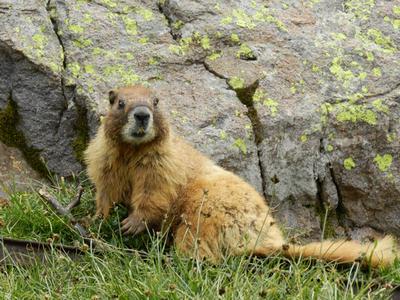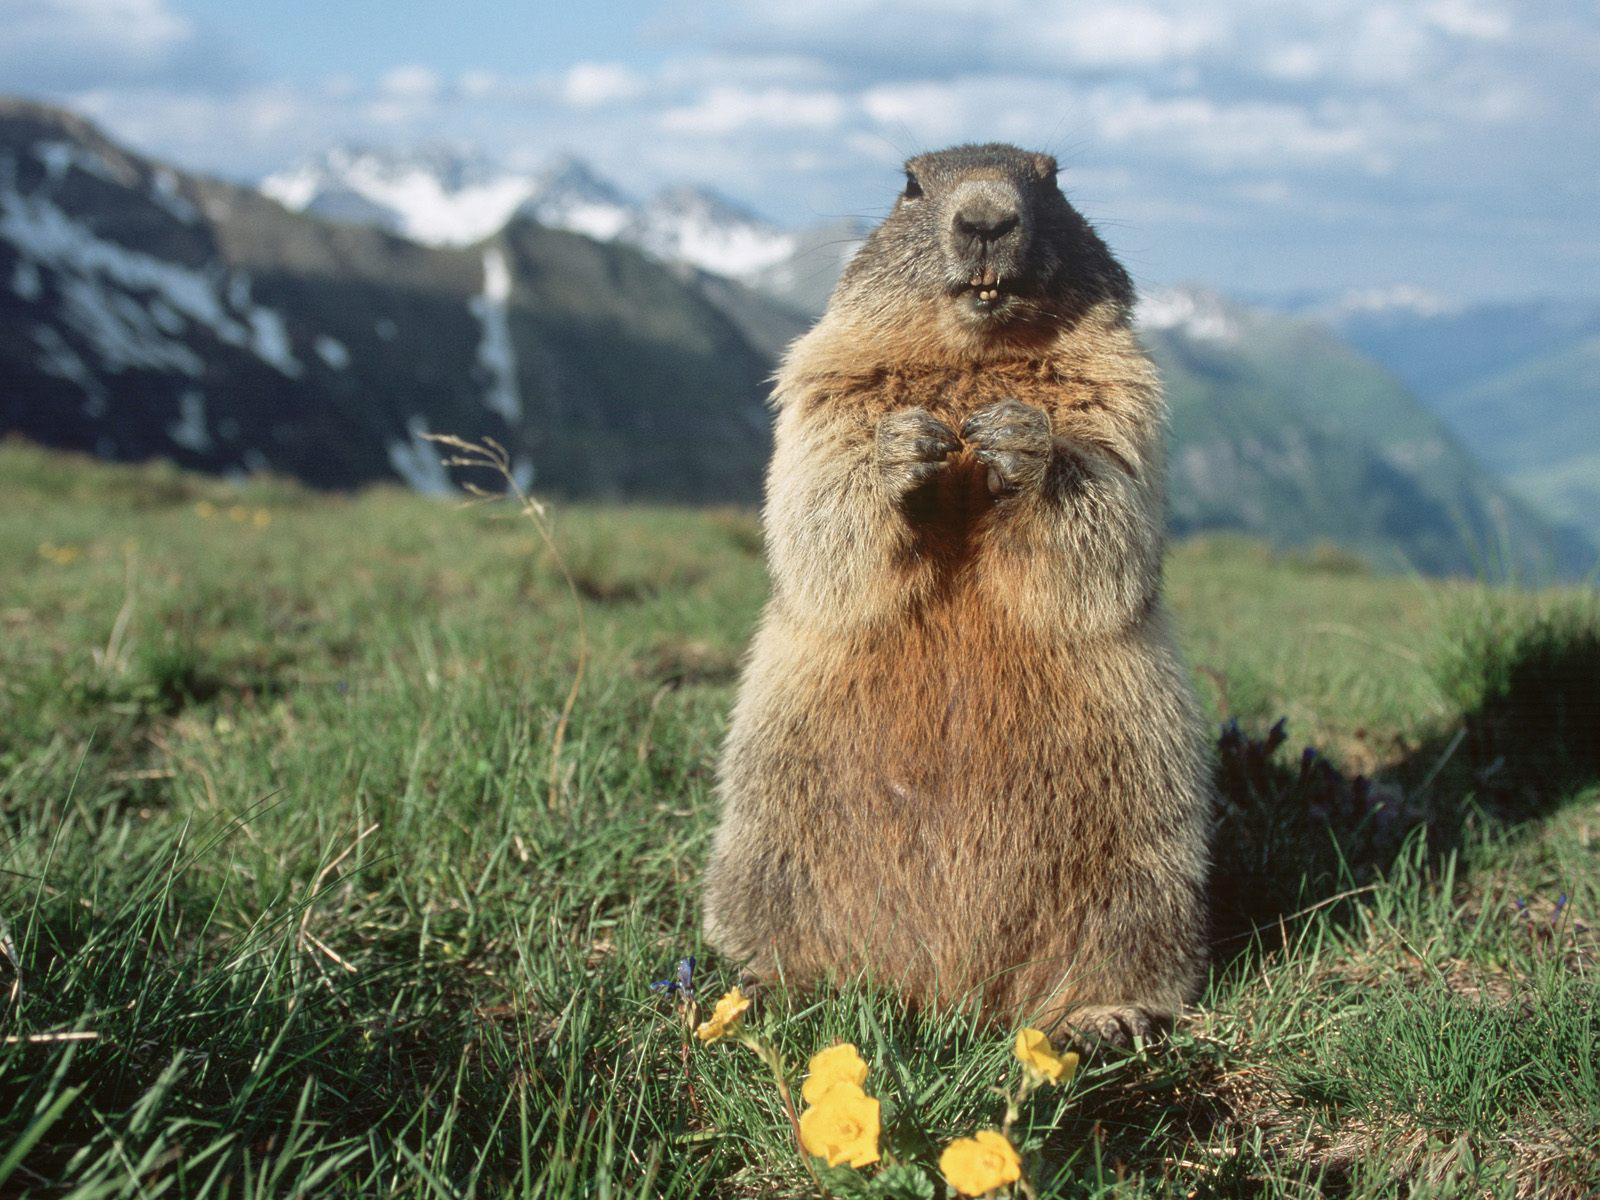The first image is the image on the left, the second image is the image on the right. For the images shown, is this caption "There is more than one animal in at least one image." true? Answer yes or no. No. 